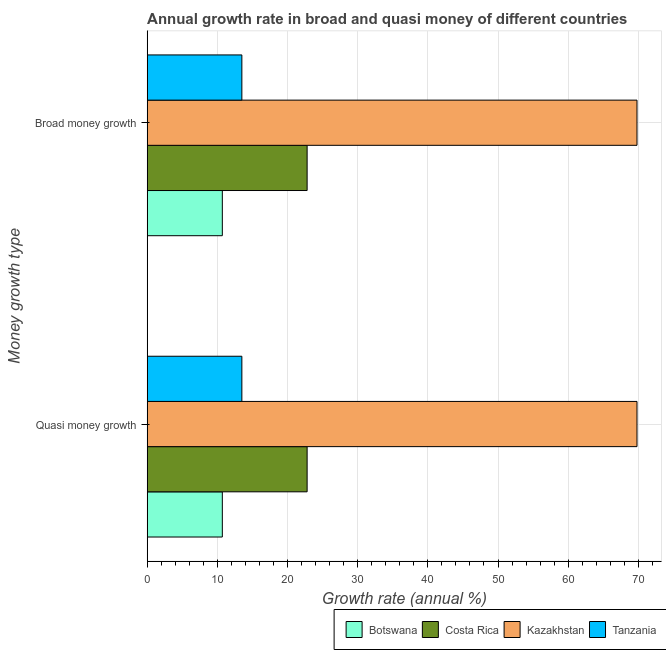How many groups of bars are there?
Your response must be concise. 2. How many bars are there on the 2nd tick from the bottom?
Make the answer very short. 4. What is the label of the 2nd group of bars from the top?
Offer a very short reply. Quasi money growth. What is the annual growth rate in broad money in Botswana?
Give a very brief answer. 10.71. Across all countries, what is the maximum annual growth rate in quasi money?
Keep it short and to the point. 69.81. Across all countries, what is the minimum annual growth rate in quasi money?
Your response must be concise. 10.71. In which country was the annual growth rate in broad money maximum?
Your response must be concise. Kazakhstan. In which country was the annual growth rate in broad money minimum?
Your answer should be very brief. Botswana. What is the total annual growth rate in quasi money in the graph?
Make the answer very short. 116.81. What is the difference between the annual growth rate in broad money in Botswana and that in Tanzania?
Offer a very short reply. -2.78. What is the difference between the annual growth rate in broad money in Tanzania and the annual growth rate in quasi money in Kazakhstan?
Your answer should be compact. -56.32. What is the average annual growth rate in quasi money per country?
Provide a succinct answer. 29.2. What is the ratio of the annual growth rate in broad money in Botswana to that in Costa Rica?
Offer a terse response. 0.47. Is the annual growth rate in broad money in Botswana less than that in Tanzania?
Offer a terse response. Yes. In how many countries, is the annual growth rate in broad money greater than the average annual growth rate in broad money taken over all countries?
Make the answer very short. 1. What does the 2nd bar from the top in Broad money growth represents?
Your response must be concise. Kazakhstan. What does the 2nd bar from the bottom in Quasi money growth represents?
Provide a short and direct response. Costa Rica. How many countries are there in the graph?
Offer a terse response. 4. How many legend labels are there?
Give a very brief answer. 4. How are the legend labels stacked?
Provide a short and direct response. Horizontal. What is the title of the graph?
Offer a very short reply. Annual growth rate in broad and quasi money of different countries. What is the label or title of the X-axis?
Give a very brief answer. Growth rate (annual %). What is the label or title of the Y-axis?
Your answer should be compact. Money growth type. What is the Growth rate (annual %) in Botswana in Quasi money growth?
Your answer should be compact. 10.71. What is the Growth rate (annual %) in Costa Rica in Quasi money growth?
Provide a succinct answer. 22.79. What is the Growth rate (annual %) in Kazakhstan in Quasi money growth?
Make the answer very short. 69.81. What is the Growth rate (annual %) in Tanzania in Quasi money growth?
Your answer should be very brief. 13.49. What is the Growth rate (annual %) in Botswana in Broad money growth?
Provide a short and direct response. 10.71. What is the Growth rate (annual %) in Costa Rica in Broad money growth?
Provide a short and direct response. 22.79. What is the Growth rate (annual %) in Kazakhstan in Broad money growth?
Offer a very short reply. 69.81. What is the Growth rate (annual %) of Tanzania in Broad money growth?
Offer a terse response. 13.49. Across all Money growth type, what is the maximum Growth rate (annual %) in Botswana?
Give a very brief answer. 10.71. Across all Money growth type, what is the maximum Growth rate (annual %) of Costa Rica?
Ensure brevity in your answer.  22.79. Across all Money growth type, what is the maximum Growth rate (annual %) in Kazakhstan?
Make the answer very short. 69.81. Across all Money growth type, what is the maximum Growth rate (annual %) of Tanzania?
Your answer should be very brief. 13.49. Across all Money growth type, what is the minimum Growth rate (annual %) in Botswana?
Make the answer very short. 10.71. Across all Money growth type, what is the minimum Growth rate (annual %) of Costa Rica?
Your answer should be compact. 22.79. Across all Money growth type, what is the minimum Growth rate (annual %) of Kazakhstan?
Ensure brevity in your answer.  69.81. Across all Money growth type, what is the minimum Growth rate (annual %) in Tanzania?
Keep it short and to the point. 13.49. What is the total Growth rate (annual %) of Botswana in the graph?
Offer a very short reply. 21.42. What is the total Growth rate (annual %) of Costa Rica in the graph?
Make the answer very short. 45.59. What is the total Growth rate (annual %) in Kazakhstan in the graph?
Offer a very short reply. 139.62. What is the total Growth rate (annual %) of Tanzania in the graph?
Offer a very short reply. 26.99. What is the difference between the Growth rate (annual %) in Botswana in Quasi money growth and that in Broad money growth?
Offer a very short reply. 0. What is the difference between the Growth rate (annual %) of Kazakhstan in Quasi money growth and that in Broad money growth?
Your answer should be compact. 0. What is the difference between the Growth rate (annual %) in Tanzania in Quasi money growth and that in Broad money growth?
Provide a succinct answer. 0. What is the difference between the Growth rate (annual %) of Botswana in Quasi money growth and the Growth rate (annual %) of Costa Rica in Broad money growth?
Make the answer very short. -12.08. What is the difference between the Growth rate (annual %) in Botswana in Quasi money growth and the Growth rate (annual %) in Kazakhstan in Broad money growth?
Offer a very short reply. -59.1. What is the difference between the Growth rate (annual %) of Botswana in Quasi money growth and the Growth rate (annual %) of Tanzania in Broad money growth?
Keep it short and to the point. -2.78. What is the difference between the Growth rate (annual %) in Costa Rica in Quasi money growth and the Growth rate (annual %) in Kazakhstan in Broad money growth?
Provide a succinct answer. -47.01. What is the difference between the Growth rate (annual %) of Costa Rica in Quasi money growth and the Growth rate (annual %) of Tanzania in Broad money growth?
Give a very brief answer. 9.3. What is the difference between the Growth rate (annual %) of Kazakhstan in Quasi money growth and the Growth rate (annual %) of Tanzania in Broad money growth?
Keep it short and to the point. 56.32. What is the average Growth rate (annual %) in Botswana per Money growth type?
Your answer should be compact. 10.71. What is the average Growth rate (annual %) of Costa Rica per Money growth type?
Provide a short and direct response. 22.79. What is the average Growth rate (annual %) in Kazakhstan per Money growth type?
Ensure brevity in your answer.  69.81. What is the average Growth rate (annual %) in Tanzania per Money growth type?
Your answer should be compact. 13.49. What is the difference between the Growth rate (annual %) of Botswana and Growth rate (annual %) of Costa Rica in Quasi money growth?
Your response must be concise. -12.08. What is the difference between the Growth rate (annual %) in Botswana and Growth rate (annual %) in Kazakhstan in Quasi money growth?
Make the answer very short. -59.1. What is the difference between the Growth rate (annual %) of Botswana and Growth rate (annual %) of Tanzania in Quasi money growth?
Provide a short and direct response. -2.78. What is the difference between the Growth rate (annual %) of Costa Rica and Growth rate (annual %) of Kazakhstan in Quasi money growth?
Your answer should be compact. -47.01. What is the difference between the Growth rate (annual %) of Costa Rica and Growth rate (annual %) of Tanzania in Quasi money growth?
Keep it short and to the point. 9.3. What is the difference between the Growth rate (annual %) of Kazakhstan and Growth rate (annual %) of Tanzania in Quasi money growth?
Provide a succinct answer. 56.32. What is the difference between the Growth rate (annual %) of Botswana and Growth rate (annual %) of Costa Rica in Broad money growth?
Make the answer very short. -12.08. What is the difference between the Growth rate (annual %) of Botswana and Growth rate (annual %) of Kazakhstan in Broad money growth?
Give a very brief answer. -59.1. What is the difference between the Growth rate (annual %) of Botswana and Growth rate (annual %) of Tanzania in Broad money growth?
Offer a very short reply. -2.78. What is the difference between the Growth rate (annual %) of Costa Rica and Growth rate (annual %) of Kazakhstan in Broad money growth?
Your response must be concise. -47.01. What is the difference between the Growth rate (annual %) in Costa Rica and Growth rate (annual %) in Tanzania in Broad money growth?
Ensure brevity in your answer.  9.3. What is the difference between the Growth rate (annual %) of Kazakhstan and Growth rate (annual %) of Tanzania in Broad money growth?
Offer a very short reply. 56.32. What is the difference between the highest and the second highest Growth rate (annual %) in Costa Rica?
Your answer should be compact. 0. What is the difference between the highest and the second highest Growth rate (annual %) of Tanzania?
Your response must be concise. 0. What is the difference between the highest and the lowest Growth rate (annual %) in Botswana?
Give a very brief answer. 0. 